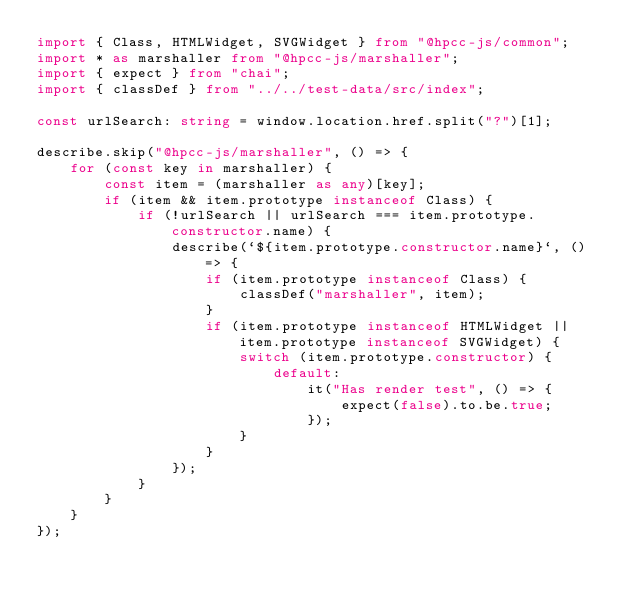Convert code to text. <code><loc_0><loc_0><loc_500><loc_500><_TypeScript_>import { Class, HTMLWidget, SVGWidget } from "@hpcc-js/common";
import * as marshaller from "@hpcc-js/marshaller";
import { expect } from "chai";
import { classDef } from "../../test-data/src/index";

const urlSearch: string = window.location.href.split("?")[1];

describe.skip("@hpcc-js/marshaller", () => {
    for (const key in marshaller) {
        const item = (marshaller as any)[key];
        if (item && item.prototype instanceof Class) {
            if (!urlSearch || urlSearch === item.prototype.constructor.name) {
                describe(`${item.prototype.constructor.name}`, () => {
                    if (item.prototype instanceof Class) {
                        classDef("marshaller", item);
                    }
                    if (item.prototype instanceof HTMLWidget || item.prototype instanceof SVGWidget) {
                        switch (item.prototype.constructor) {
                            default:
                                it("Has render test", () => {
                                    expect(false).to.be.true;
                                });
                        }
                    }
                });
            }
        }
    }
});
</code> 